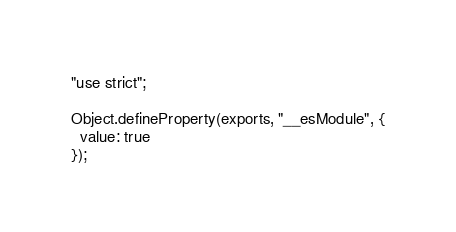Convert code to text. <code><loc_0><loc_0><loc_500><loc_500><_JavaScript_>"use strict";

Object.defineProperty(exports, "__esModule", {
  value: true
});</code> 